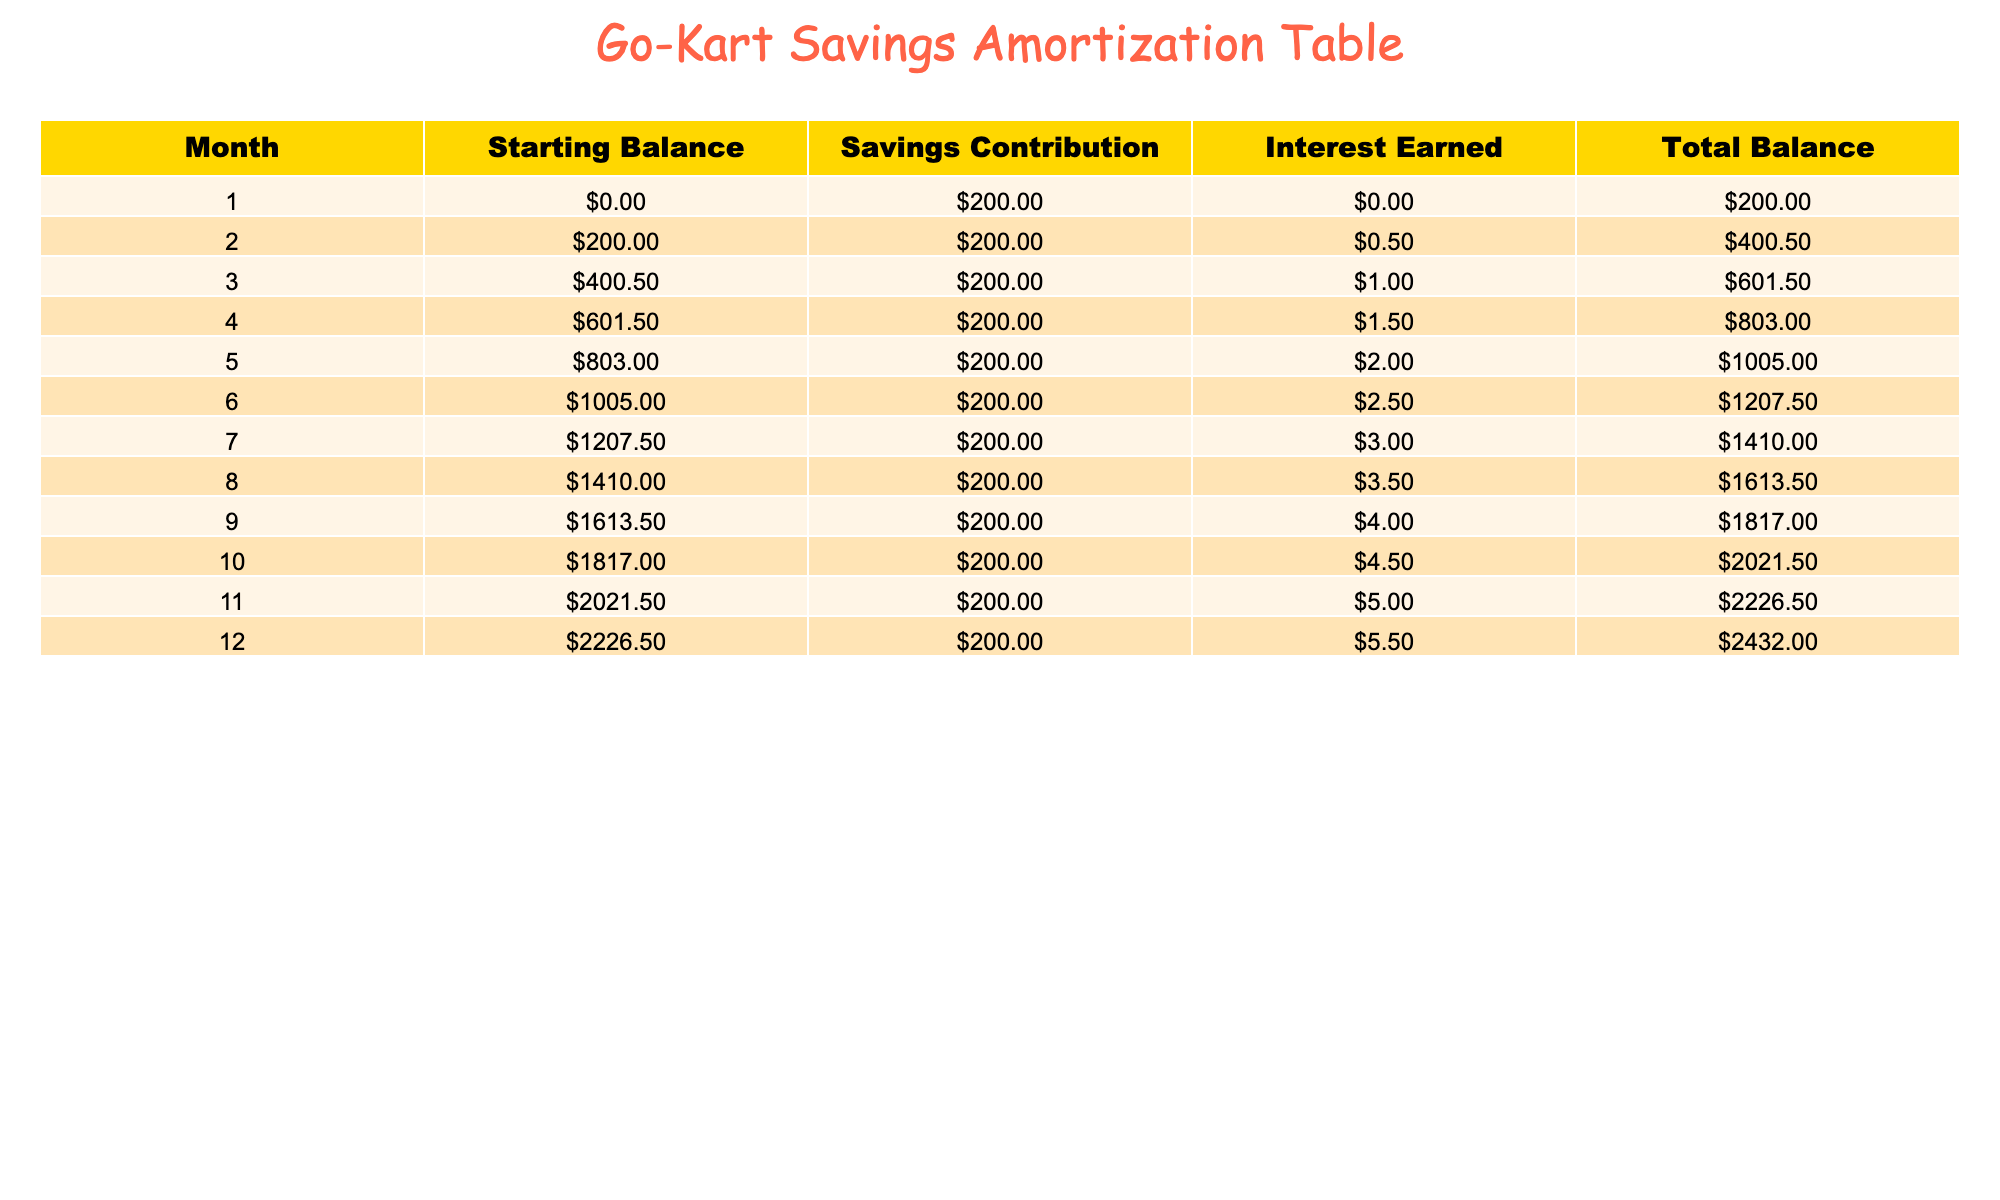What was the total savings contribution after 6 months? The savings contribution is fixed at $200 each month. After 6 months, the total contribution is calculated as 6 months * $200/month = $1200.
Answer: 1200 What was the interest earned in month 10? The interest earned in month 10 is directly stated in the table as $4.5.
Answer: 4.5 What is the total balance at the end of the 12th month? The total balance at the end of the 12th month is listed as $2432 in the table.
Answer: 2432 Was the interest earned in the 5th month greater than $2? The interest for the 5th month is $2, so it is not greater than $2, making the statement false.
Answer: No How much more total balance did the savings show at the end of month 12 compared to month 6? The total balance at the end of month 12 is $2432 and at month 6 is $1207.5. The difference is $2432 - $1207.5 = $1224.5.
Answer: 1224.5 What was the average interest earned per month over the 12 months? The total interest earned can be calculated as the sum of the monthly interests: 0 + 0.5 + 1 + 1.5 + 2 + 2.5 + 3 + 3.5 + 4 + 4.5 + 5 + 5.5 = 29. The average interest earned is then 29 / 12 = 2.42 approximately.
Answer: 2.42 How many months had a total balance greater than $1800? The total balance values over 12 months are checked: $200, $400.5, $601.5, $803, $1005, $1207.5, $1410, $1613.5, $1817, $2021.5, $2226.5, $2432. The months with a total balance greater than $1800 are months 10, 11, and 12. Therefore, there are 3 months.
Answer: 3 Is the total balance at the end of month 3 less than $600? The total balance at the end of month 3 is $601.5, which is not less than $600, making the statement false.
Answer: No What is the increase in total balance from month 1 to month 5? The total balance in month 1 is $200 and in month 5 it is $1005. The increase is calculated as $1005 - $200 = $805.
Answer: 805 